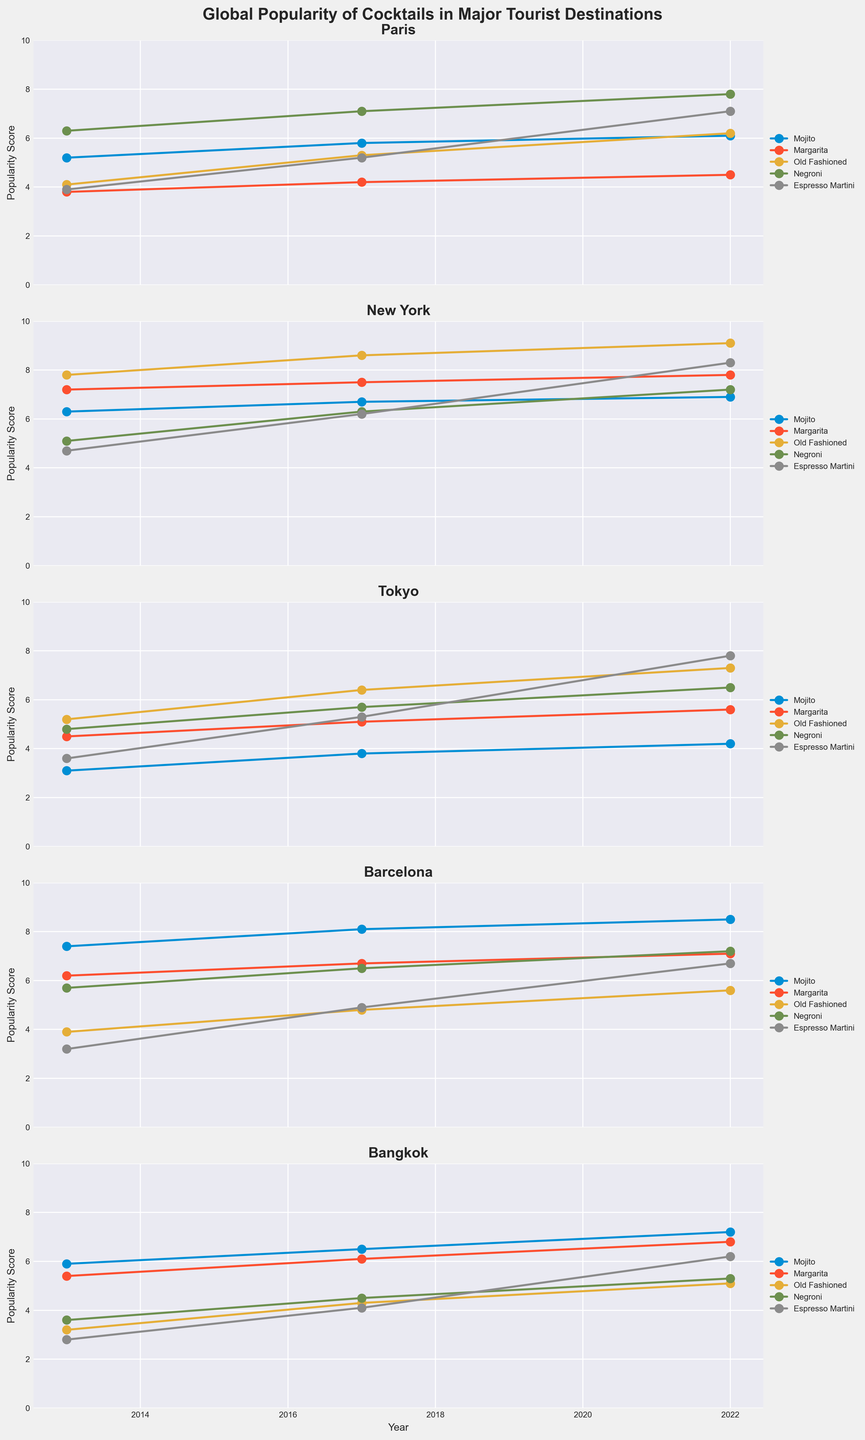What's the overall trend of Mojito popularity in Paris from 2013 to 2022? To determine the trend, observe the plotted values for Mojito in Paris over the three time points. In 2013, the score is 5.2, increasing to 5.8 in 2017, and reaching 6.1 in 2022. This indicates a consistent upward trend.
Answer: Increasing Which cocktail had the highest popularity score in New York in 2022? Look at the plot for New York in 2022 and compare the popularity scores of all cocktails. Old Fashioned has the highest score with 9.1.
Answer: Old Fashioned What differences can be seen in the popularity of Negroni in Tokyo from 2013 to 2022? Note the Negroni scores in Tokyo for each year: 4.8 in 2013, 5.7 in 2017, and 6.5 in 2022. Calculate the differences: from 2013 to 2017 (5.7 - 4.8 = 0.9) and from 2017 to 2022 (6.5 - 5.7 = 0.8).
Answer: 0.9 and 0.8 Which destination had the lowest popularity score for Espresso Martini in 2013? Compare the 2013 values for Espresso Martini across all destinations. Paris: 3.9, New York: 4.7, Tokyo: 3.6, Barcelona: 3.2, and Bangkok: 2.8. The lowest score is in Bangkok.
Answer: Bangkok Is the popularity of Margarita in Barcelona always higher than in Tokyo in each observed year? Compare the Margarita scores between Barcelona and Tokyo for each year. 2013: Barcelona (6.2) vs. Tokyo (4.5), 2017: Barcelona (6.7) vs. Tokyo (5.1), 2022: Barcelona (7.1) vs. Tokyo (5.6). Barcelona's score is consistently higher.
Answer: Yes How has the popularity of Old Fashioned changed in Bangkok between 2013 and 2022? Observe the Old Fashioned scores in Bangkok over the years: 3.2 in 2013, 4.3 in 2017, and 5.1 in 2022. The popularity has increased steadily.
Answer: Increasing What’s the average popularity score of Margarita across all destinations in 2017? Add the Margarita scores for 2017 from each destination. Paris: 4.2, New York: 7.5, Tokyo: 5.1, Barcelona: 6.7, Bangkok: 6.1. Sum: 4.2 + 7.5 + 5.1 + 6.7 + 6.1 = 29.6. Average: 29.6 / 5 = 5.92.
Answer: 5.92 Which destination shows the greatest increase in Mojito popularity between 2013 and 2022? Calculate the increase for each destination: Paris (6.1-5.2=0.9), New York (6.9-6.3=0.6), Tokyo (4.2-3.1=1.1), Barcelona (8.5-7.4=1.1), and Bangkok (7.2-5.9=1.3). Bangkok shows the greatest increase.
Answer: Bangkok In 2022, which cocktail had the closest popularity scores in both Tokyo and Barcelona, and what were those scores? Compare 2022 values for each cocktail in Tokyo and Barcelona. Mojito: Tokyo (4.2) vs. Barcelona (8.5), Margarita: Tokyo (5.6) vs. Barcelona (7.1), Old Fashioned: Tokyo (7.3) vs. Barcelona (5.6), Negroni: Tokyo (6.5) vs. Barcelona (7.2), Espresso Martini: Tokyo (7.8) vs. Barcelona (6.7). Negroni scores are closest: Tokyo (6.5) and Barcelona (7.2), difference = 0.7.
Answer: Negroni, Tokyo: 6.5, Barcelona: 7.2 